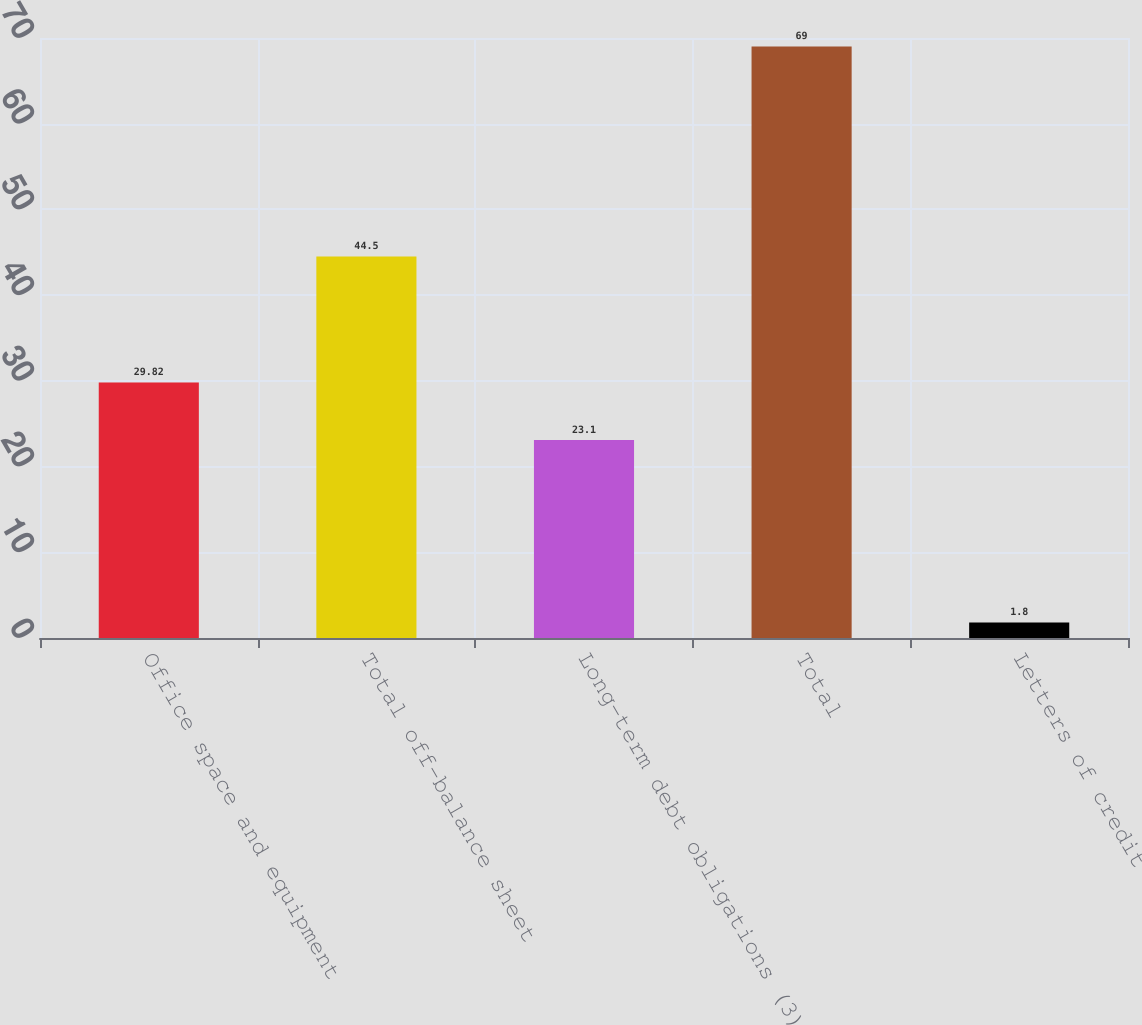Convert chart. <chart><loc_0><loc_0><loc_500><loc_500><bar_chart><fcel>Office space and equipment<fcel>Total off-balance sheet<fcel>Long-term debt obligations (3)<fcel>Total<fcel>Letters of credit<nl><fcel>29.82<fcel>44.5<fcel>23.1<fcel>69<fcel>1.8<nl></chart> 